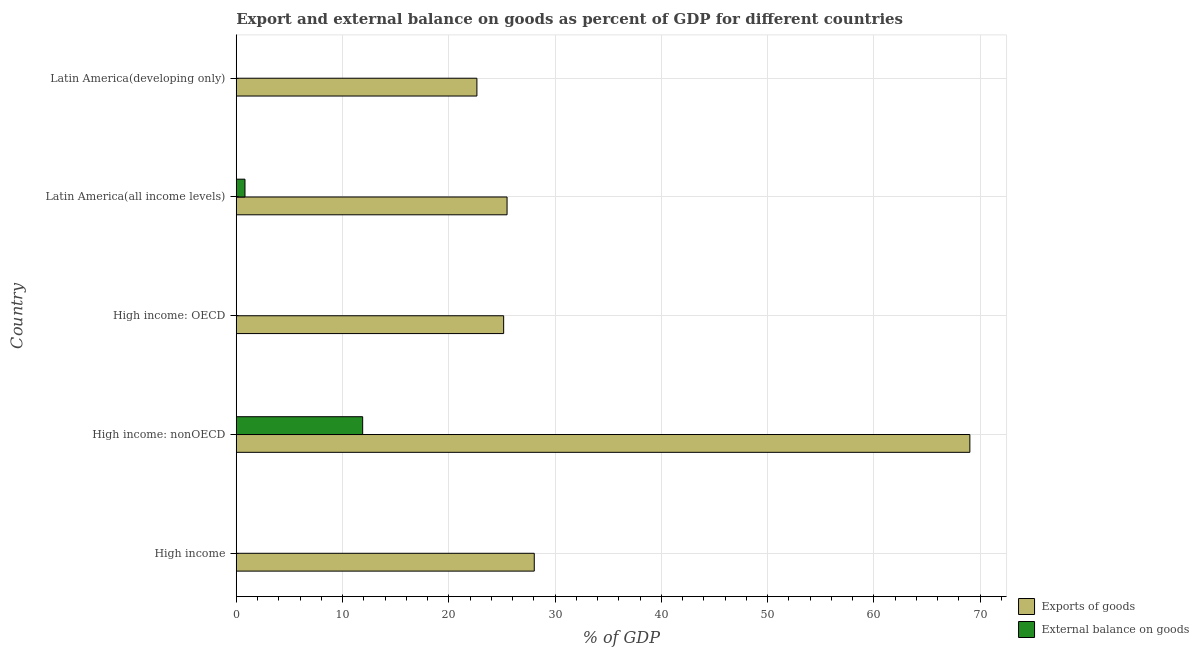How many different coloured bars are there?
Provide a succinct answer. 2. Are the number of bars per tick equal to the number of legend labels?
Keep it short and to the point. No. Are the number of bars on each tick of the Y-axis equal?
Your response must be concise. No. How many bars are there on the 1st tick from the bottom?
Your answer should be very brief. 1. What is the label of the 1st group of bars from the top?
Offer a very short reply. Latin America(developing only). What is the external balance on goods as percentage of gdp in High income: nonOECD?
Offer a very short reply. 11.9. Across all countries, what is the maximum export of goods as percentage of gdp?
Your answer should be very brief. 69.04. Across all countries, what is the minimum export of goods as percentage of gdp?
Offer a terse response. 22.65. In which country was the export of goods as percentage of gdp maximum?
Offer a very short reply. High income: nonOECD. What is the total external balance on goods as percentage of gdp in the graph?
Provide a short and direct response. 12.72. What is the difference between the export of goods as percentage of gdp in High income: OECD and that in Latin America(all income levels)?
Give a very brief answer. -0.32. What is the difference between the external balance on goods as percentage of gdp in High income: nonOECD and the export of goods as percentage of gdp in Latin America(all income levels)?
Offer a very short reply. -13.59. What is the average external balance on goods as percentage of gdp per country?
Give a very brief answer. 2.54. What is the difference between the external balance on goods as percentage of gdp and export of goods as percentage of gdp in Latin America(all income levels)?
Provide a short and direct response. -24.66. In how many countries, is the export of goods as percentage of gdp greater than 42 %?
Ensure brevity in your answer.  1. What is the ratio of the export of goods as percentage of gdp in High income to that in High income: OECD?
Offer a terse response. 1.11. What is the difference between the highest and the second highest export of goods as percentage of gdp?
Your answer should be very brief. 41. What is the difference between the highest and the lowest external balance on goods as percentage of gdp?
Offer a terse response. 11.9. In how many countries, is the external balance on goods as percentage of gdp greater than the average external balance on goods as percentage of gdp taken over all countries?
Ensure brevity in your answer.  1. How many countries are there in the graph?
Your response must be concise. 5. Are the values on the major ticks of X-axis written in scientific E-notation?
Make the answer very short. No. Does the graph contain any zero values?
Give a very brief answer. Yes. How many legend labels are there?
Your answer should be compact. 2. How are the legend labels stacked?
Offer a very short reply. Vertical. What is the title of the graph?
Ensure brevity in your answer.  Export and external balance on goods as percent of GDP for different countries. Does "Net National savings" appear as one of the legend labels in the graph?
Ensure brevity in your answer.  No. What is the label or title of the X-axis?
Your answer should be very brief. % of GDP. What is the label or title of the Y-axis?
Your answer should be compact. Country. What is the % of GDP in Exports of goods in High income?
Provide a succinct answer. 28.05. What is the % of GDP in Exports of goods in High income: nonOECD?
Your answer should be very brief. 69.04. What is the % of GDP in External balance on goods in High income: nonOECD?
Offer a terse response. 11.9. What is the % of GDP of Exports of goods in High income: OECD?
Provide a succinct answer. 25.17. What is the % of GDP of External balance on goods in High income: OECD?
Your answer should be compact. 0. What is the % of GDP in Exports of goods in Latin America(all income levels)?
Ensure brevity in your answer.  25.49. What is the % of GDP of External balance on goods in Latin America(all income levels)?
Your response must be concise. 0.82. What is the % of GDP of Exports of goods in Latin America(developing only)?
Provide a succinct answer. 22.65. Across all countries, what is the maximum % of GDP in Exports of goods?
Keep it short and to the point. 69.04. Across all countries, what is the maximum % of GDP in External balance on goods?
Provide a short and direct response. 11.9. Across all countries, what is the minimum % of GDP of Exports of goods?
Offer a terse response. 22.65. Across all countries, what is the minimum % of GDP of External balance on goods?
Your response must be concise. 0. What is the total % of GDP in Exports of goods in the graph?
Offer a very short reply. 170.39. What is the total % of GDP of External balance on goods in the graph?
Your answer should be very brief. 12.72. What is the difference between the % of GDP in Exports of goods in High income and that in High income: nonOECD?
Offer a very short reply. -41. What is the difference between the % of GDP of Exports of goods in High income and that in High income: OECD?
Your answer should be very brief. 2.88. What is the difference between the % of GDP in Exports of goods in High income and that in Latin America(all income levels)?
Your response must be concise. 2.56. What is the difference between the % of GDP in Exports of goods in High income and that in Latin America(developing only)?
Offer a very short reply. 5.4. What is the difference between the % of GDP of Exports of goods in High income: nonOECD and that in High income: OECD?
Keep it short and to the point. 43.88. What is the difference between the % of GDP of Exports of goods in High income: nonOECD and that in Latin America(all income levels)?
Your answer should be compact. 43.56. What is the difference between the % of GDP of External balance on goods in High income: nonOECD and that in Latin America(all income levels)?
Provide a short and direct response. 11.08. What is the difference between the % of GDP of Exports of goods in High income: nonOECD and that in Latin America(developing only)?
Your answer should be compact. 46.39. What is the difference between the % of GDP of Exports of goods in High income: OECD and that in Latin America(all income levels)?
Your response must be concise. -0.32. What is the difference between the % of GDP of Exports of goods in High income: OECD and that in Latin America(developing only)?
Offer a very short reply. 2.52. What is the difference between the % of GDP in Exports of goods in Latin America(all income levels) and that in Latin America(developing only)?
Your answer should be compact. 2.84. What is the difference between the % of GDP of Exports of goods in High income and the % of GDP of External balance on goods in High income: nonOECD?
Provide a short and direct response. 16.15. What is the difference between the % of GDP of Exports of goods in High income and the % of GDP of External balance on goods in Latin America(all income levels)?
Your answer should be compact. 27.22. What is the difference between the % of GDP in Exports of goods in High income: nonOECD and the % of GDP in External balance on goods in Latin America(all income levels)?
Give a very brief answer. 68.22. What is the difference between the % of GDP of Exports of goods in High income: OECD and the % of GDP of External balance on goods in Latin America(all income levels)?
Keep it short and to the point. 24.34. What is the average % of GDP in Exports of goods per country?
Provide a short and direct response. 34.08. What is the average % of GDP in External balance on goods per country?
Offer a very short reply. 2.54. What is the difference between the % of GDP in Exports of goods and % of GDP in External balance on goods in High income: nonOECD?
Your answer should be compact. 57.15. What is the difference between the % of GDP of Exports of goods and % of GDP of External balance on goods in Latin America(all income levels)?
Your answer should be very brief. 24.67. What is the ratio of the % of GDP of Exports of goods in High income to that in High income: nonOECD?
Give a very brief answer. 0.41. What is the ratio of the % of GDP in Exports of goods in High income to that in High income: OECD?
Your answer should be compact. 1.11. What is the ratio of the % of GDP in Exports of goods in High income to that in Latin America(all income levels)?
Your response must be concise. 1.1. What is the ratio of the % of GDP in Exports of goods in High income to that in Latin America(developing only)?
Your answer should be very brief. 1.24. What is the ratio of the % of GDP of Exports of goods in High income: nonOECD to that in High income: OECD?
Your answer should be compact. 2.74. What is the ratio of the % of GDP of Exports of goods in High income: nonOECD to that in Latin America(all income levels)?
Your answer should be compact. 2.71. What is the ratio of the % of GDP of External balance on goods in High income: nonOECD to that in Latin America(all income levels)?
Provide a succinct answer. 14.47. What is the ratio of the % of GDP of Exports of goods in High income: nonOECD to that in Latin America(developing only)?
Ensure brevity in your answer.  3.05. What is the ratio of the % of GDP of Exports of goods in High income: OECD to that in Latin America(all income levels)?
Keep it short and to the point. 0.99. What is the ratio of the % of GDP in Exports of goods in High income: OECD to that in Latin America(developing only)?
Provide a succinct answer. 1.11. What is the ratio of the % of GDP in Exports of goods in Latin America(all income levels) to that in Latin America(developing only)?
Give a very brief answer. 1.13. What is the difference between the highest and the second highest % of GDP of Exports of goods?
Ensure brevity in your answer.  41. What is the difference between the highest and the lowest % of GDP in Exports of goods?
Give a very brief answer. 46.39. What is the difference between the highest and the lowest % of GDP in External balance on goods?
Give a very brief answer. 11.9. 